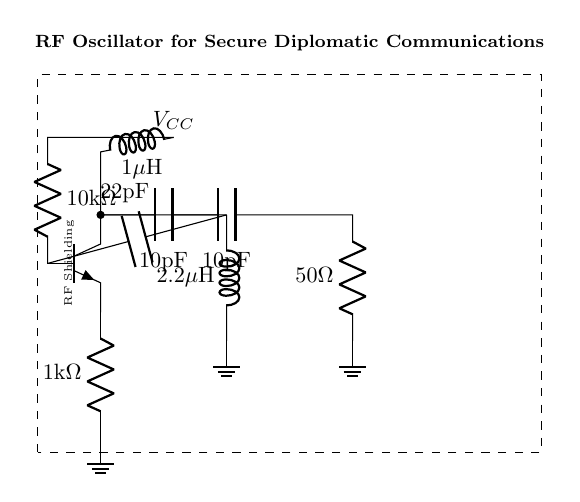What is the resistance of R1? The resistance of R1 is given as 10k ohms in the circuit diagram.
Answer: 10kΩ What is the capacitance of C1? The capacitance of C1 is indicated in the diagram as 10 picofarads.
Answer: 10pF What component is used for feedback in this oscillator? The feedback in this oscillator is provided by the combination of capacitors C1 and C2 and the inductor L2 as shown in the connections.
Answer: C1, C2, L2 What is the total inductance in the circuit? The total inductance is the sum of L1 and L2. L1 is 1 microhenry, and L2 is 2.2 microhenries, totaling 3.2 microhenries.
Answer: 3.2µH How does this RF oscillator ensure secure communication? The RF oscillator operates at a specific frequency that can be tuned to avoid interception, utilizing frequency stability and components that enhance signal integrity for secure communication.
Answer: Frequency stability What is the purpose of C3 in the output stage? C3 serves as a coupling capacitor in the output stage, allowing AC signals to pass while blocking DC components, thereby isolating the oscillator from the load.
Answer: Coupling capacitor What does the dashed rectangle represent in the circuit diagram? The dashed rectangle indicates RF shielding, which is essential for minimizing interference and ensuring secure signal transmission in diplomatic communications.
Answer: RF Shielding 